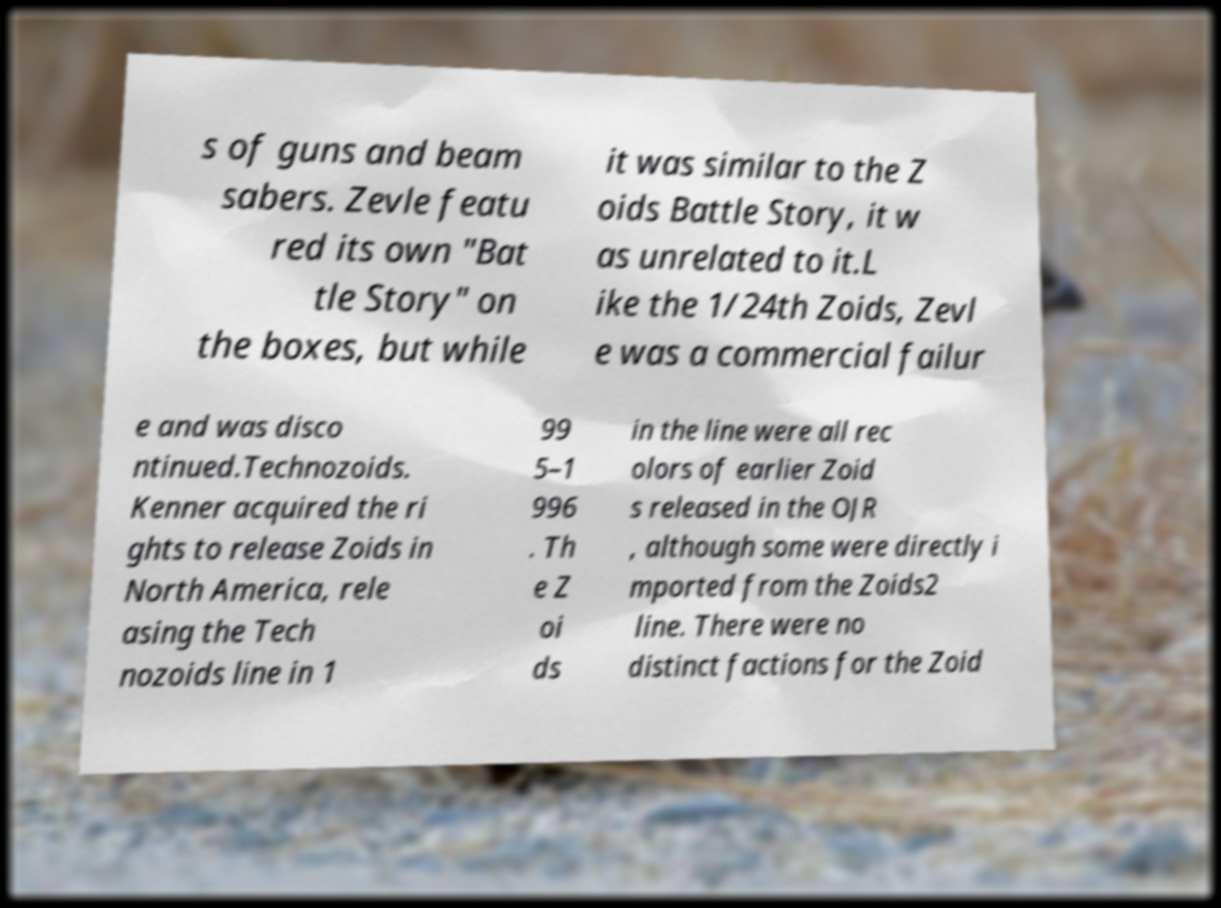Can you accurately transcribe the text from the provided image for me? s of guns and beam sabers. Zevle featu red its own "Bat tle Story" on the boxes, but while it was similar to the Z oids Battle Story, it w as unrelated to it.L ike the 1/24th Zoids, Zevl e was a commercial failur e and was disco ntinued.Technozoids. Kenner acquired the ri ghts to release Zoids in North America, rele asing the Tech nozoids line in 1 99 5–1 996 . Th e Z oi ds in the line were all rec olors of earlier Zoid s released in the OJR , although some were directly i mported from the Zoids2 line. There were no distinct factions for the Zoid 